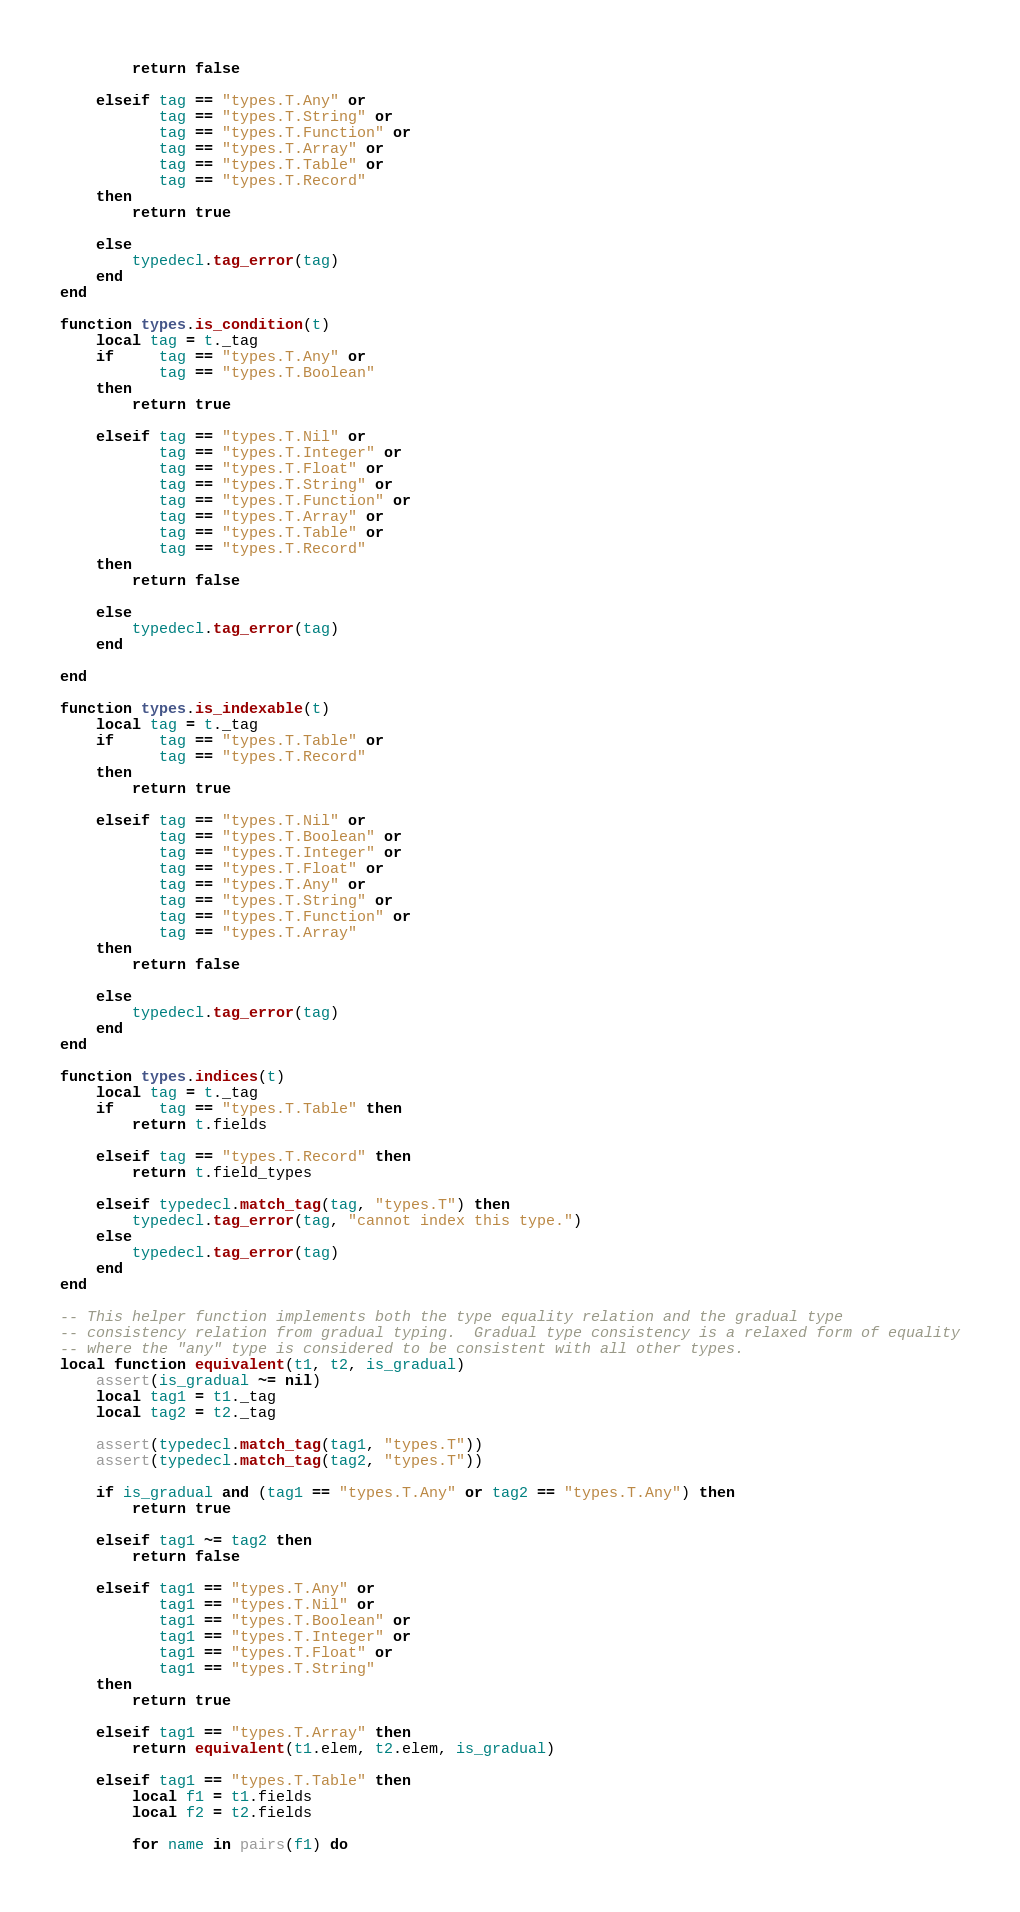<code> <loc_0><loc_0><loc_500><loc_500><_Lua_>        return false

    elseif tag == "types.T.Any" or
           tag == "types.T.String" or
           tag == "types.T.Function" or
           tag == "types.T.Array" or
           tag == "types.T.Table" or
           tag == "types.T.Record"
    then
        return true

    else
        typedecl.tag_error(tag)
    end
end

function types.is_condition(t)
    local tag = t._tag
    if     tag == "types.T.Any" or
           tag == "types.T.Boolean"
    then
        return true

    elseif tag == "types.T.Nil" or
           tag == "types.T.Integer" or
           tag == "types.T.Float" or
           tag == "types.T.String" or
           tag == "types.T.Function" or
           tag == "types.T.Array" or
           tag == "types.T.Table" or
           tag == "types.T.Record"
    then
        return false

    else
        typedecl.tag_error(tag)
    end

end

function types.is_indexable(t)
    local tag = t._tag
    if     tag == "types.T.Table" or
           tag == "types.T.Record"
    then
        return true

    elseif tag == "types.T.Nil" or
           tag == "types.T.Boolean" or
           tag == "types.T.Integer" or
           tag == "types.T.Float" or
           tag == "types.T.Any" or
           tag == "types.T.String" or
           tag == "types.T.Function" or
           tag == "types.T.Array"
    then
        return false

    else
        typedecl.tag_error(tag)
    end
end

function types.indices(t)
    local tag = t._tag
    if     tag == "types.T.Table" then
        return t.fields

    elseif tag == "types.T.Record" then
        return t.field_types

    elseif typedecl.match_tag(tag, "types.T") then
        typedecl.tag_error(tag, "cannot index this type.")
    else
        typedecl.tag_error(tag)
    end
end

-- This helper function implements both the type equality relation and the gradual type
-- consistency relation from gradual typing.  Gradual type consistency is a relaxed form of equality
-- where the "any" type is considered to be consistent with all other types.
local function equivalent(t1, t2, is_gradual)
    assert(is_gradual ~= nil)
    local tag1 = t1._tag
    local tag2 = t2._tag

    assert(typedecl.match_tag(tag1, "types.T"))
    assert(typedecl.match_tag(tag2, "types.T"))

    if is_gradual and (tag1 == "types.T.Any" or tag2 == "types.T.Any") then
        return true

    elseif tag1 ~= tag2 then
        return false

    elseif tag1 == "types.T.Any" or
           tag1 == "types.T.Nil" or
           tag1 == "types.T.Boolean" or
           tag1 == "types.T.Integer" or
           tag1 == "types.T.Float" or
           tag1 == "types.T.String"
    then
        return true

    elseif tag1 == "types.T.Array" then
        return equivalent(t1.elem, t2.elem, is_gradual)

    elseif tag1 == "types.T.Table" then
        local f1 = t1.fields
        local f2 = t2.fields

        for name in pairs(f1) do</code> 